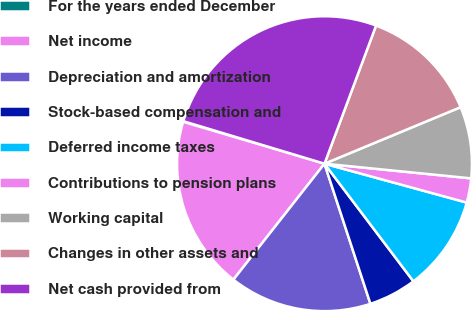Convert chart. <chart><loc_0><loc_0><loc_500><loc_500><pie_chart><fcel>For the years ended December<fcel>Net income<fcel>Depreciation and amortization<fcel>Stock-based compensation and<fcel>Deferred income taxes<fcel>Contributions to pension plans<fcel>Working capital<fcel>Changes in other assets and<fcel>Net cash provided from<nl><fcel>0.07%<fcel>18.99%<fcel>15.64%<fcel>5.26%<fcel>10.45%<fcel>2.66%<fcel>7.85%<fcel>13.05%<fcel>26.03%<nl></chart> 